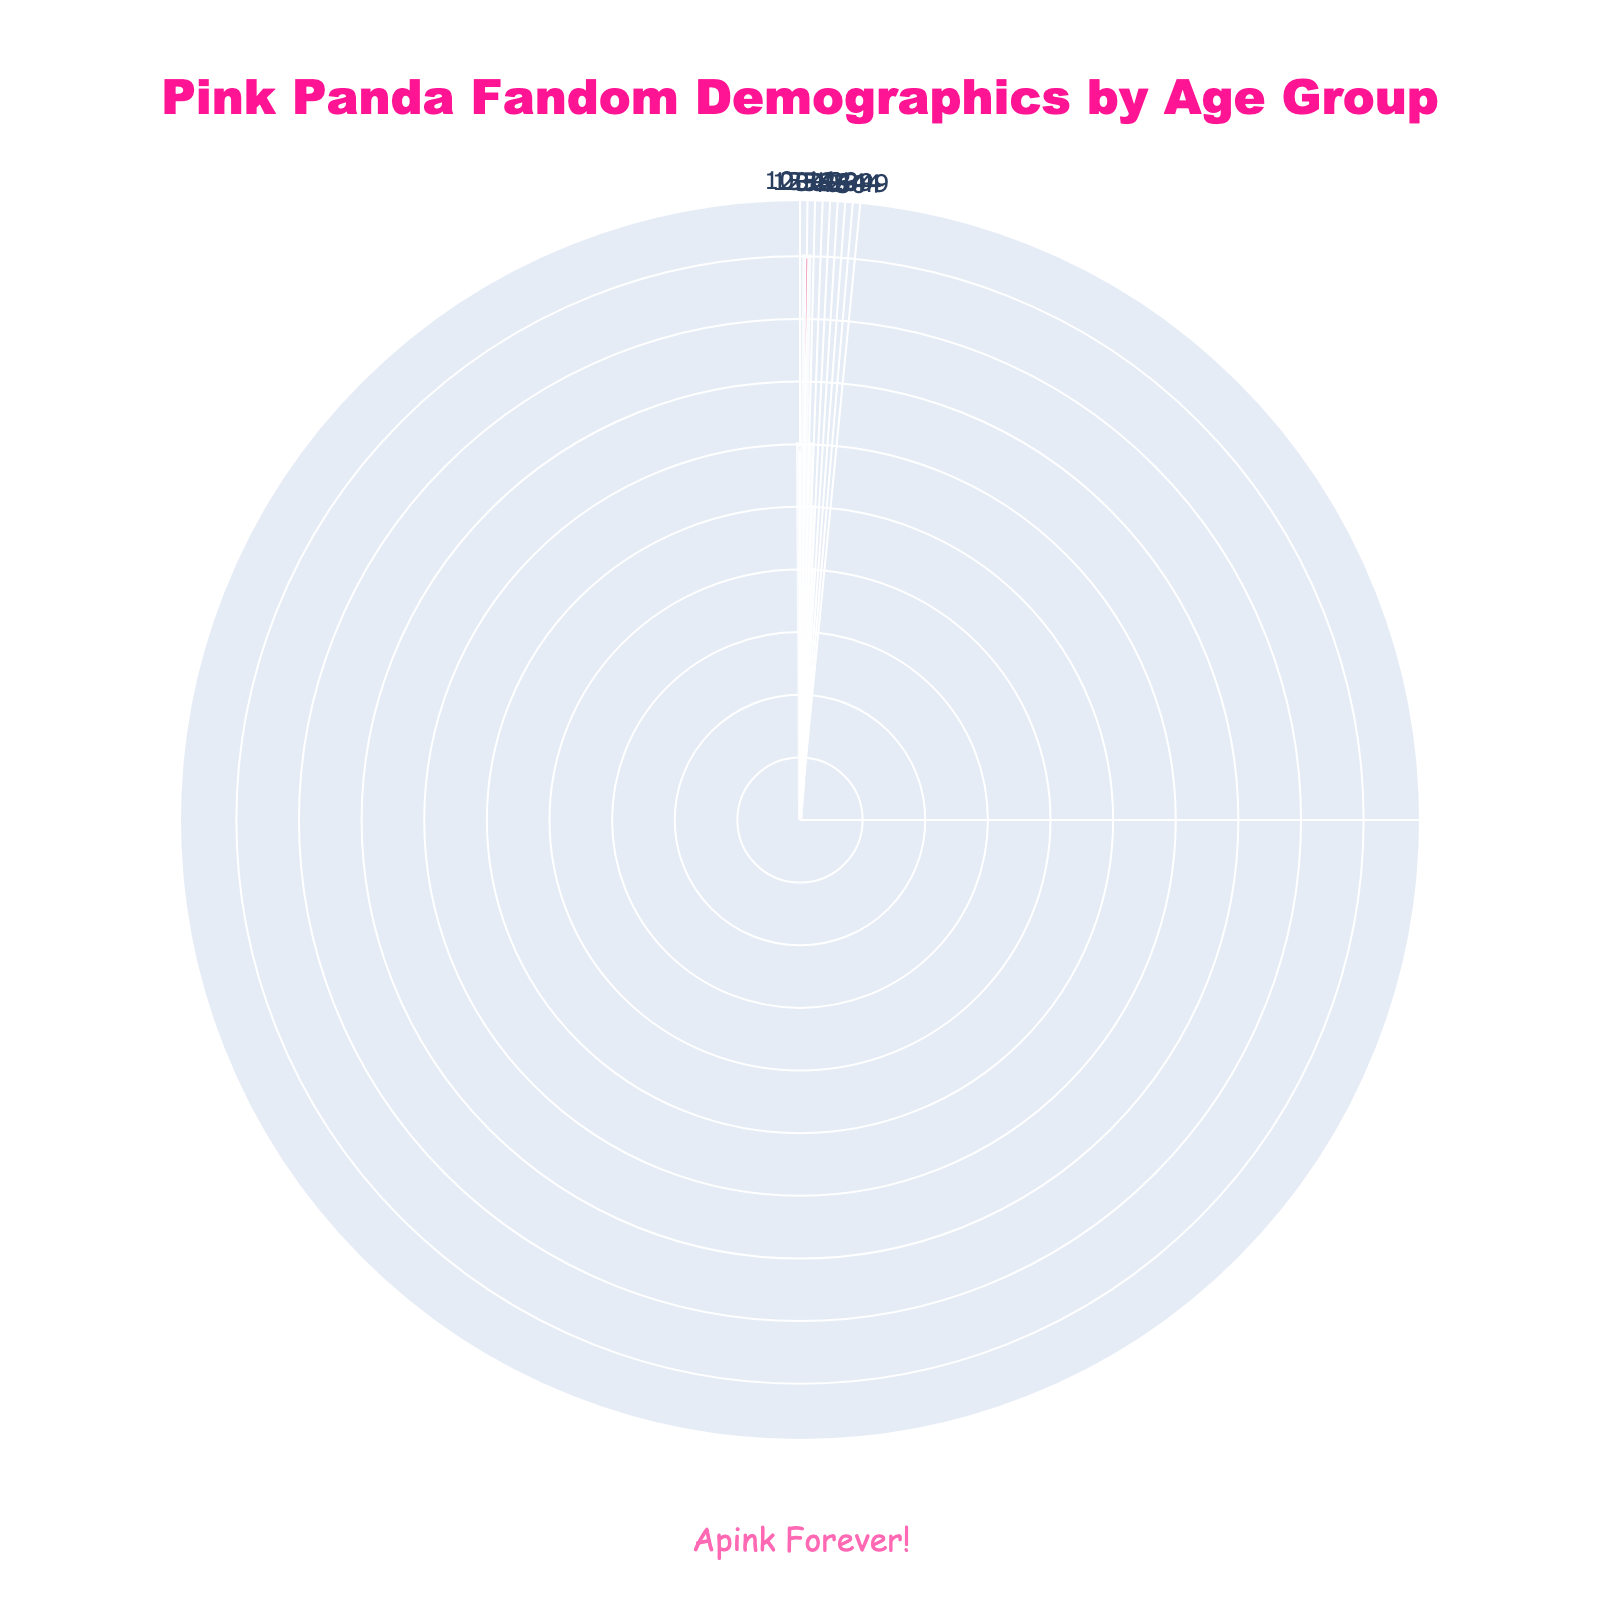What is the title of the chart? The title of the chart is displayed at the top and reads "Pink Panda Fandom Demographics by Age Group".
Answer: Pink Panda Fandom Demographics by Age Group How many age groups are represented in the chart? The chart consists of segments for each age group; by counting them, we get a total of 9 distinct age groups.
Answer: 9 Which age group has the largest number of Pink Panda fans? By examining the lengths of the bars, the age group with the largest radius is the "15-19" group.
Answer: 15-19 What is the total number of fans in the age groups from 20-34? Adding the "20-24" (3000), "25-29" (2500), and "30-34" (2000) groups: 3000 + 2500 + 2000 = 7500.
Answer: 7500 Which two age groups have the smallest number of fans, and what are their counts? The smallest segments are for "45-49" (300 fans) and "50+" (100 fans).
Answer: 45-49: 300, 50+: 100 How do the number of fans in the "10-14" group compare to the "35-39" group? By comparing the lengths of the corresponding bars, the "10-14" group has more fans (1500) than the "35-39" group (1000).
Answer: 10-14 > 35-39 What is the average number of fans across all age groups? Sum all the fan counts: 1500 + 4500 + 3000 + 2500 + 2000 + 1000 + 700 + 300 + 100 = 15600, then divide by the number of groups (9): 15600 / 9 ≈ 1733.33.
Answer: 1733.33 What percentage of the total fans do those between 15-19 years old represent? First calculate the proportion of fans in the "15-19" group (4500) of the total (15600): (4500 / 15600) * 100 ≈ 28.85%.
Answer: 28.85% Which age group has a fan count closest to the average number of fans? The average number is 1733.33, and the closest group count is "10-14" with 1500 fans.
Answer: 10-14 How does the fan count for the age group "25-29" compare to "30-34"? By comparing their bar lengths, "25-29" has more fans (2500) than "30-34" (2000).
Answer: 25-29 > 30-34 